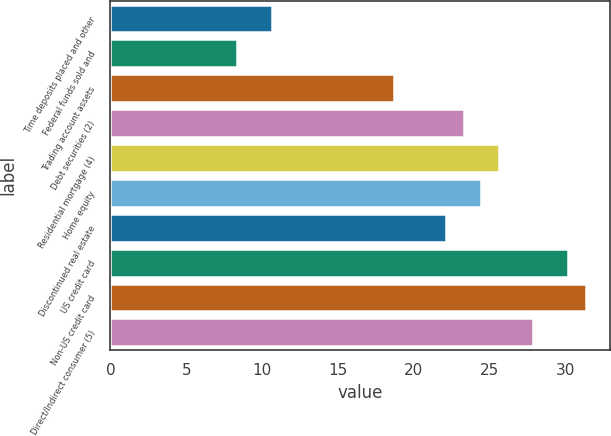Convert chart to OTSL. <chart><loc_0><loc_0><loc_500><loc_500><bar_chart><fcel>Time deposits placed and other<fcel>Federal funds sold and<fcel>Trading account assets<fcel>Debt securities (2)<fcel>Residential mortgage (4)<fcel>Home equity<fcel>Discontinued real estate<fcel>US credit card<fcel>Non-US credit card<fcel>Direct/Indirect consumer (5)<nl><fcel>10.63<fcel>8.33<fcel>18.68<fcel>23.28<fcel>25.58<fcel>24.43<fcel>22.13<fcel>30.18<fcel>31.33<fcel>27.88<nl></chart> 